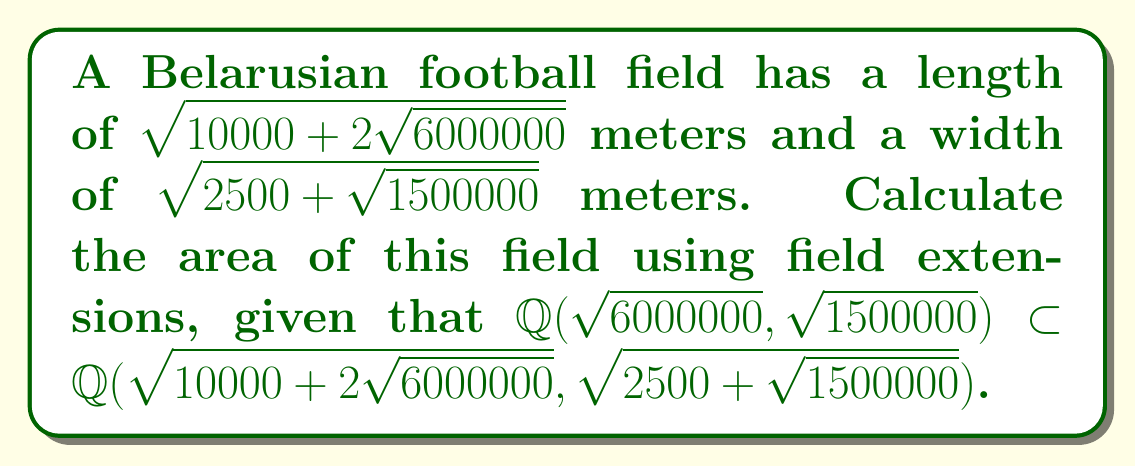Can you answer this question? 1) First, let's simplify the given expressions:
   $\sqrt{6000000} = 1000\sqrt{6}$
   $\sqrt{1500000} = 500\sqrt{6}$

2) Now, the length $l = \sqrt{10000 + 2\sqrt{6000000}} = \sqrt{10000 + 2000\sqrt{6}}$
   The width $w = \sqrt{2500 + \sqrt{1500000}} = \sqrt{2500 + 500\sqrt{6}}$

3) To calculate the area, we need to multiply $l$ and $w$:
   $A = l \cdot w = \sqrt{10000 + 2000\sqrt{6}} \cdot \sqrt{2500 + 500\sqrt{6}}$

4) Using the field extension property, we know that:
   $\mathbb{Q}(\sqrt{6}) \subset \mathbb{Q}(\sqrt{10000 + 2000\sqrt{6}}, \sqrt{2500 + 500\sqrt{6}})$

5) This means we can rationalize the surds:
   $A = \sqrt{(10000 + 2000\sqrt{6})(2500 + 500\sqrt{6})}$

6) Expanding the expression under the square root:
   $A = \sqrt{25000000 + 5000000\sqrt{6} + 5000000\sqrt{6} + 1000000 \cdot 6}$
   $A = \sqrt{31000000 + 10000000\sqrt{6}}$

7) Simplifying further:
   $A = \sqrt{31000000 + 10000000\sqrt{6}}$
   $A = 1000\sqrt{31000 + 10000\sqrt{6}}$

8) The final area is in square meters.
Answer: $1000\sqrt{31000 + 10000\sqrt{6}}$ m² 